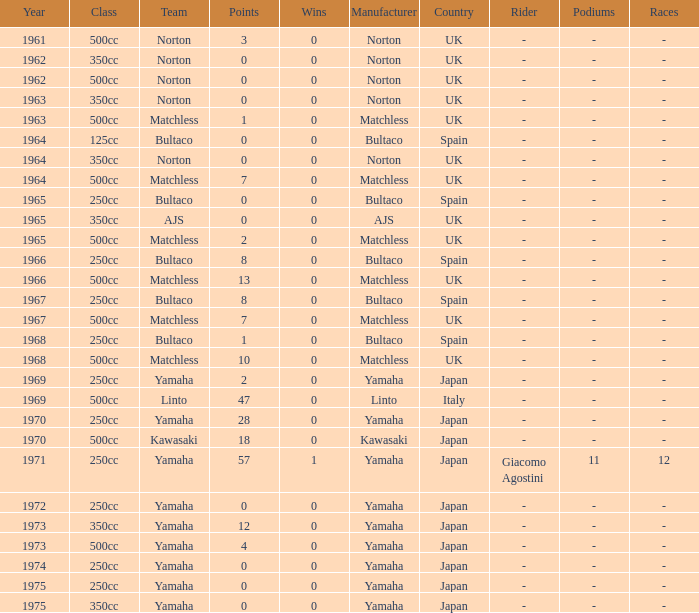What is the sum of all points in 1975 with 0 wins? None. 